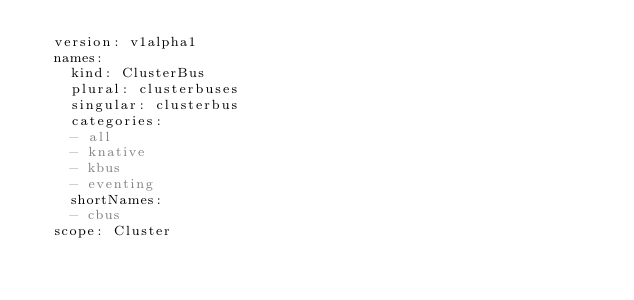Convert code to text. <code><loc_0><loc_0><loc_500><loc_500><_YAML_>  version: v1alpha1
  names:
    kind: ClusterBus
    plural: clusterbuses
    singular: clusterbus
    categories:
    - all
    - knative
    - kbus
    - eventing
    shortNames:
    - cbus
  scope: Cluster
</code> 